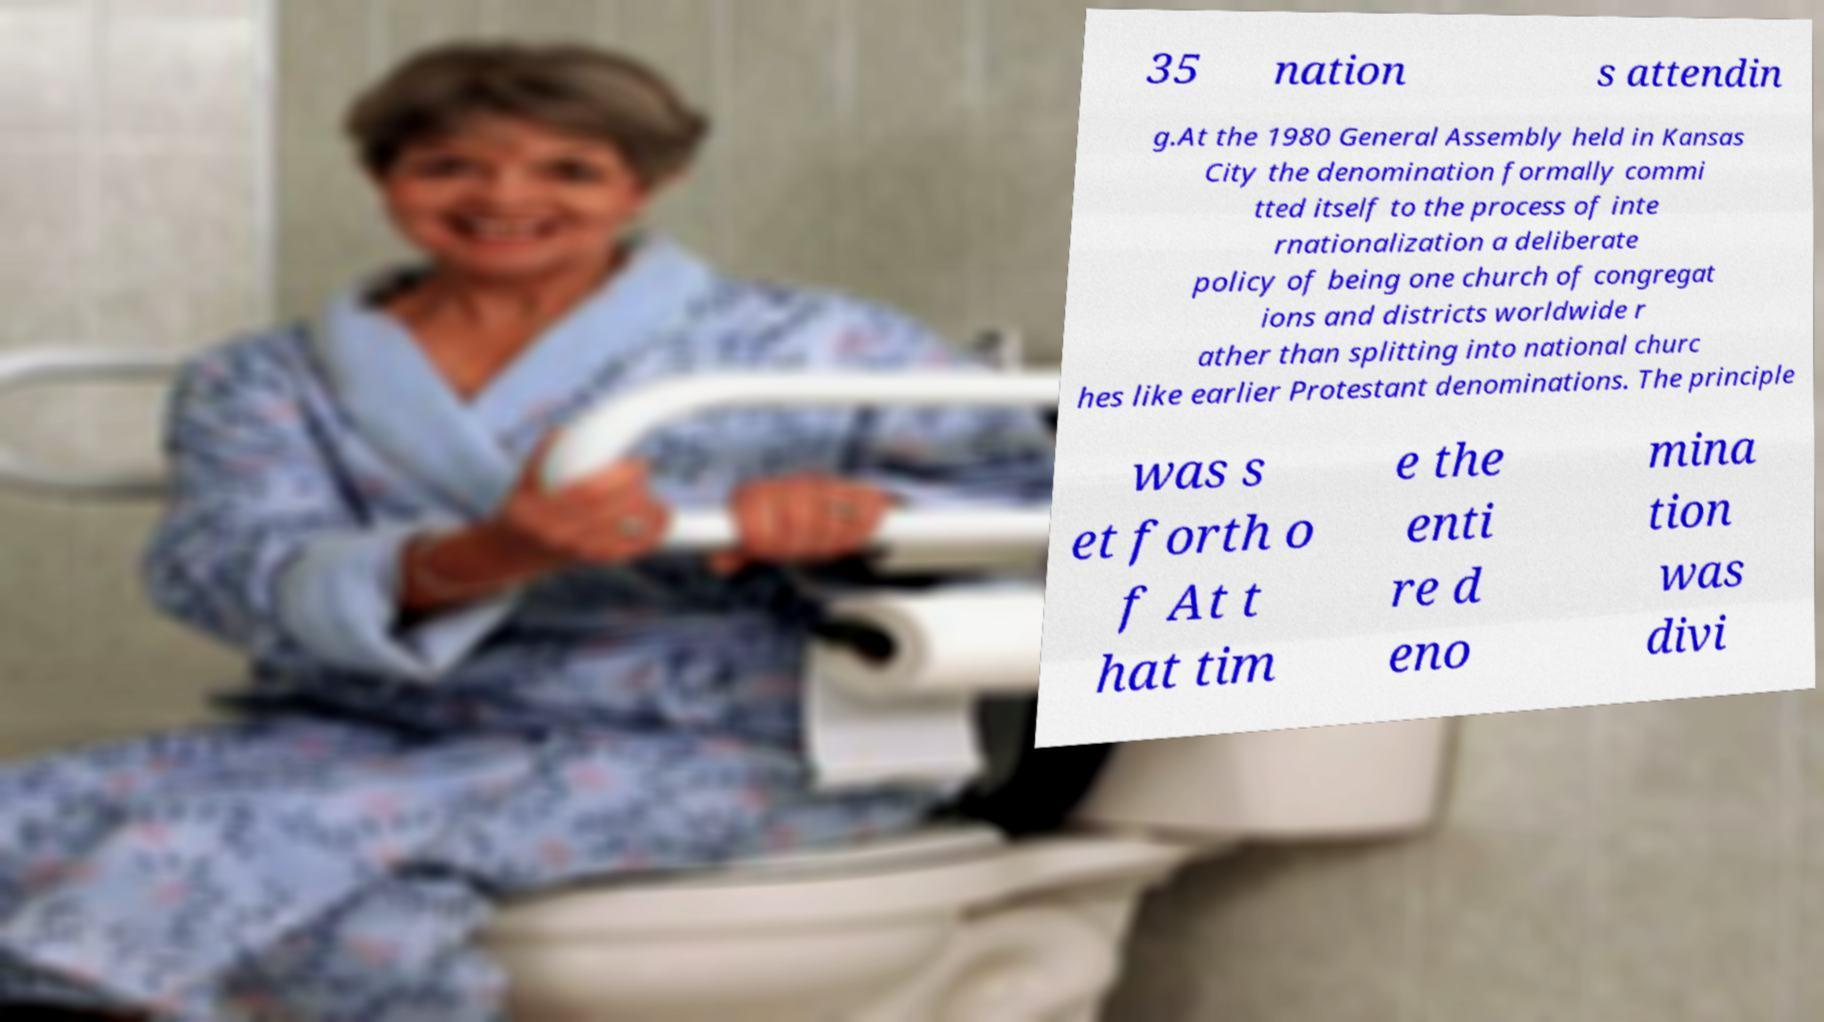I need the written content from this picture converted into text. Can you do that? 35 nation s attendin g.At the 1980 General Assembly held in Kansas City the denomination formally commi tted itself to the process of inte rnationalization a deliberate policy of being one church of congregat ions and districts worldwide r ather than splitting into national churc hes like earlier Protestant denominations. The principle was s et forth o f At t hat tim e the enti re d eno mina tion was divi 